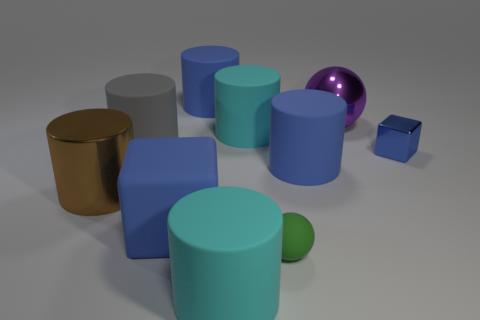What color is the large shiny object that is to the left of the blue cylinder behind the metallic sphere?
Provide a succinct answer. Brown. Is the number of small yellow matte cylinders greater than the number of blocks?
Ensure brevity in your answer.  No. How many other metallic cubes are the same size as the metallic cube?
Your answer should be compact. 0. Is the material of the brown object the same as the large cyan cylinder in front of the small sphere?
Offer a very short reply. No. Is the number of spheres less than the number of large brown metal cylinders?
Your response must be concise. No. Is there anything else that has the same color as the small rubber ball?
Keep it short and to the point. No. The gray object that is the same material as the small green ball is what shape?
Offer a very short reply. Cylinder. How many big things are to the left of the blue cylinder that is in front of the object that is behind the big purple metal thing?
Make the answer very short. 6. The large object that is both to the right of the green object and in front of the big sphere has what shape?
Provide a succinct answer. Cylinder. Are there fewer cyan rubber objects that are on the right side of the blue metal object than green balls?
Provide a short and direct response. Yes. 